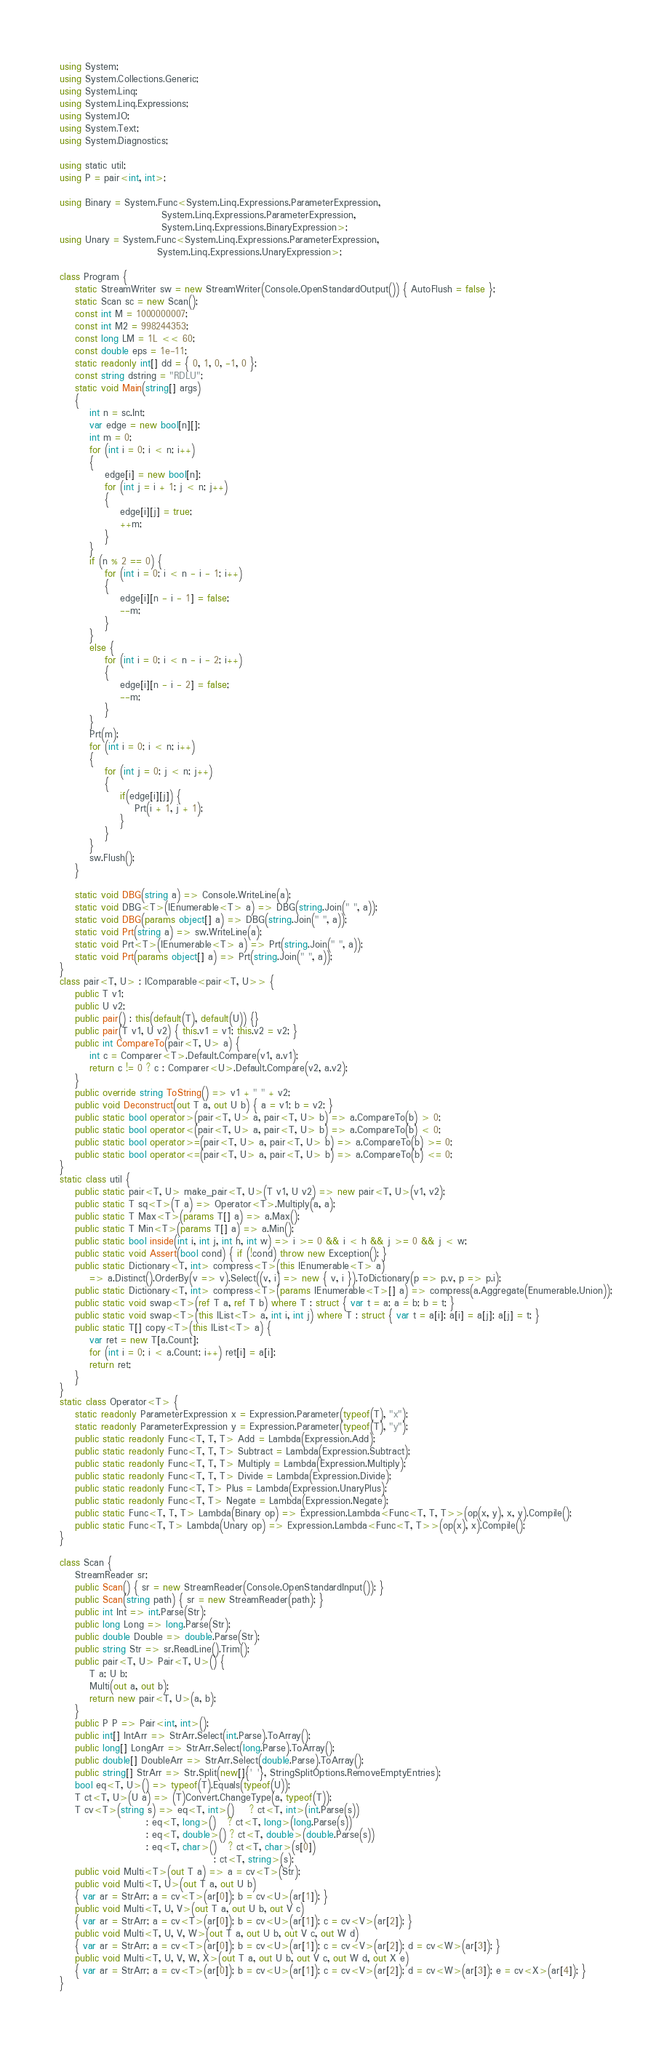<code> <loc_0><loc_0><loc_500><loc_500><_C#_>using System;
using System.Collections.Generic;
using System.Linq;
using System.Linq.Expressions;
using System.IO;
using System.Text;
using System.Diagnostics;

using static util;
using P = pair<int, int>;

using Binary = System.Func<System.Linq.Expressions.ParameterExpression,
                           System.Linq.Expressions.ParameterExpression,
                           System.Linq.Expressions.BinaryExpression>;
using Unary = System.Func<System.Linq.Expressions.ParameterExpression,
                          System.Linq.Expressions.UnaryExpression>;

class Program {
    static StreamWriter sw = new StreamWriter(Console.OpenStandardOutput()) { AutoFlush = false };
    static Scan sc = new Scan();
    const int M = 1000000007;
    const int M2 = 998244353;
    const long LM = 1L << 60;
    const double eps = 1e-11;
    static readonly int[] dd = { 0, 1, 0, -1, 0 };
    const string dstring = "RDLU";
    static void Main(string[] args)
    {
        int n = sc.Int;
        var edge = new bool[n][];
        int m = 0;
        for (int i = 0; i < n; i++)
        {
            edge[i] = new bool[n];
            for (int j = i + 1; j < n; j++)
            {
                edge[i][j] = true;
                ++m;
            }
        }
        if (n % 2 == 0) {
            for (int i = 0; i < n - i - 1; i++)
            {
                edge[i][n - i - 1] = false;
                --m;
            }
        }
        else {
            for (int i = 0; i < n - i - 2; i++)
            {
                edge[i][n - i - 2] = false;
                --m;
            }
        }
        Prt(m);
        for (int i = 0; i < n; i++)
        {
            for (int j = 0; j < n; j++)
            {
                if(edge[i][j]) {
                    Prt(i + 1, j + 1);
                }
            }
        }
        sw.Flush();
    }

    static void DBG(string a) => Console.WriteLine(a);
    static void DBG<T>(IEnumerable<T> a) => DBG(string.Join(" ", a));
    static void DBG(params object[] a) => DBG(string.Join(" ", a));
    static void Prt(string a) => sw.WriteLine(a);
    static void Prt<T>(IEnumerable<T> a) => Prt(string.Join(" ", a));
    static void Prt(params object[] a) => Prt(string.Join(" ", a));
}
class pair<T, U> : IComparable<pair<T, U>> {
    public T v1;
    public U v2;
    public pair() : this(default(T), default(U)) {}
    public pair(T v1, U v2) { this.v1 = v1; this.v2 = v2; }
    public int CompareTo(pair<T, U> a) {
        int c = Comparer<T>.Default.Compare(v1, a.v1);
        return c != 0 ? c : Comparer<U>.Default.Compare(v2, a.v2);
    }
    public override string ToString() => v1 + " " + v2;
    public void Deconstruct(out T a, out U b) { a = v1; b = v2; }
    public static bool operator>(pair<T, U> a, pair<T, U> b) => a.CompareTo(b) > 0;
    public static bool operator<(pair<T, U> a, pair<T, U> b) => a.CompareTo(b) < 0;
    public static bool operator>=(pair<T, U> a, pair<T, U> b) => a.CompareTo(b) >= 0;
    public static bool operator<=(pair<T, U> a, pair<T, U> b) => a.CompareTo(b) <= 0;
}
static class util {
    public static pair<T, U> make_pair<T, U>(T v1, U v2) => new pair<T, U>(v1, v2);
    public static T sq<T>(T a) => Operator<T>.Multiply(a, a);
    public static T Max<T>(params T[] a) => a.Max();
    public static T Min<T>(params T[] a) => a.Min();
    public static bool inside(int i, int j, int h, int w) => i >= 0 && i < h && j >= 0 && j < w;
    public static void Assert(bool cond) { if (!cond) throw new Exception(); }
    public static Dictionary<T, int> compress<T>(this IEnumerable<T> a)
        => a.Distinct().OrderBy(v => v).Select((v, i) => new { v, i }).ToDictionary(p => p.v, p => p.i);
    public static Dictionary<T, int> compress<T>(params IEnumerable<T>[] a) => compress(a.Aggregate(Enumerable.Union));
    public static void swap<T>(ref T a, ref T b) where T : struct { var t = a; a = b; b = t; }
    public static void swap<T>(this IList<T> a, int i, int j) where T : struct { var t = a[i]; a[i] = a[j]; a[j] = t; }
    public static T[] copy<T>(this IList<T> a) {
        var ret = new T[a.Count];
        for (int i = 0; i < a.Count; i++) ret[i] = a[i];
        return ret;
    }
}
static class Operator<T> {
    static readonly ParameterExpression x = Expression.Parameter(typeof(T), "x");
    static readonly ParameterExpression y = Expression.Parameter(typeof(T), "y");
    public static readonly Func<T, T, T> Add = Lambda(Expression.Add);
    public static readonly Func<T, T, T> Subtract = Lambda(Expression.Subtract);
    public static readonly Func<T, T, T> Multiply = Lambda(Expression.Multiply);
    public static readonly Func<T, T, T> Divide = Lambda(Expression.Divide);
    public static readonly Func<T, T> Plus = Lambda(Expression.UnaryPlus);
    public static readonly Func<T, T> Negate = Lambda(Expression.Negate);
    public static Func<T, T, T> Lambda(Binary op) => Expression.Lambda<Func<T, T, T>>(op(x, y), x, y).Compile();
    public static Func<T, T> Lambda(Unary op) => Expression.Lambda<Func<T, T>>(op(x), x).Compile();
}

class Scan {
    StreamReader sr;
    public Scan() { sr = new StreamReader(Console.OpenStandardInput()); }
    public Scan(string path) { sr = new StreamReader(path); }
    public int Int => int.Parse(Str);
    public long Long => long.Parse(Str);
    public double Double => double.Parse(Str);
    public string Str => sr.ReadLine().Trim();
    public pair<T, U> Pair<T, U>() {
        T a; U b;
        Multi(out a, out b);
        return new pair<T, U>(a, b);
    }
    public P P => Pair<int, int>();
    public int[] IntArr => StrArr.Select(int.Parse).ToArray();
    public long[] LongArr => StrArr.Select(long.Parse).ToArray();
    public double[] DoubleArr => StrArr.Select(double.Parse).ToArray();
    public string[] StrArr => Str.Split(new[]{' '}, StringSplitOptions.RemoveEmptyEntries);
    bool eq<T, U>() => typeof(T).Equals(typeof(U));
    T ct<T, U>(U a) => (T)Convert.ChangeType(a, typeof(T));
    T cv<T>(string s) => eq<T, int>()    ? ct<T, int>(int.Parse(s))
                       : eq<T, long>()   ? ct<T, long>(long.Parse(s))
                       : eq<T, double>() ? ct<T, double>(double.Parse(s))
                       : eq<T, char>()   ? ct<T, char>(s[0])
                                         : ct<T, string>(s);
    public void Multi<T>(out T a) => a = cv<T>(Str);
    public void Multi<T, U>(out T a, out U b)
    { var ar = StrArr; a = cv<T>(ar[0]); b = cv<U>(ar[1]); }
    public void Multi<T, U, V>(out T a, out U b, out V c)
    { var ar = StrArr; a = cv<T>(ar[0]); b = cv<U>(ar[1]); c = cv<V>(ar[2]); }
    public void Multi<T, U, V, W>(out T a, out U b, out V c, out W d)
    { var ar = StrArr; a = cv<T>(ar[0]); b = cv<U>(ar[1]); c = cv<V>(ar[2]); d = cv<W>(ar[3]); }
    public void Multi<T, U, V, W, X>(out T a, out U b, out V c, out W d, out X e)
    { var ar = StrArr; a = cv<T>(ar[0]); b = cv<U>(ar[1]); c = cv<V>(ar[2]); d = cv<W>(ar[3]); e = cv<X>(ar[4]); }
}
</code> 